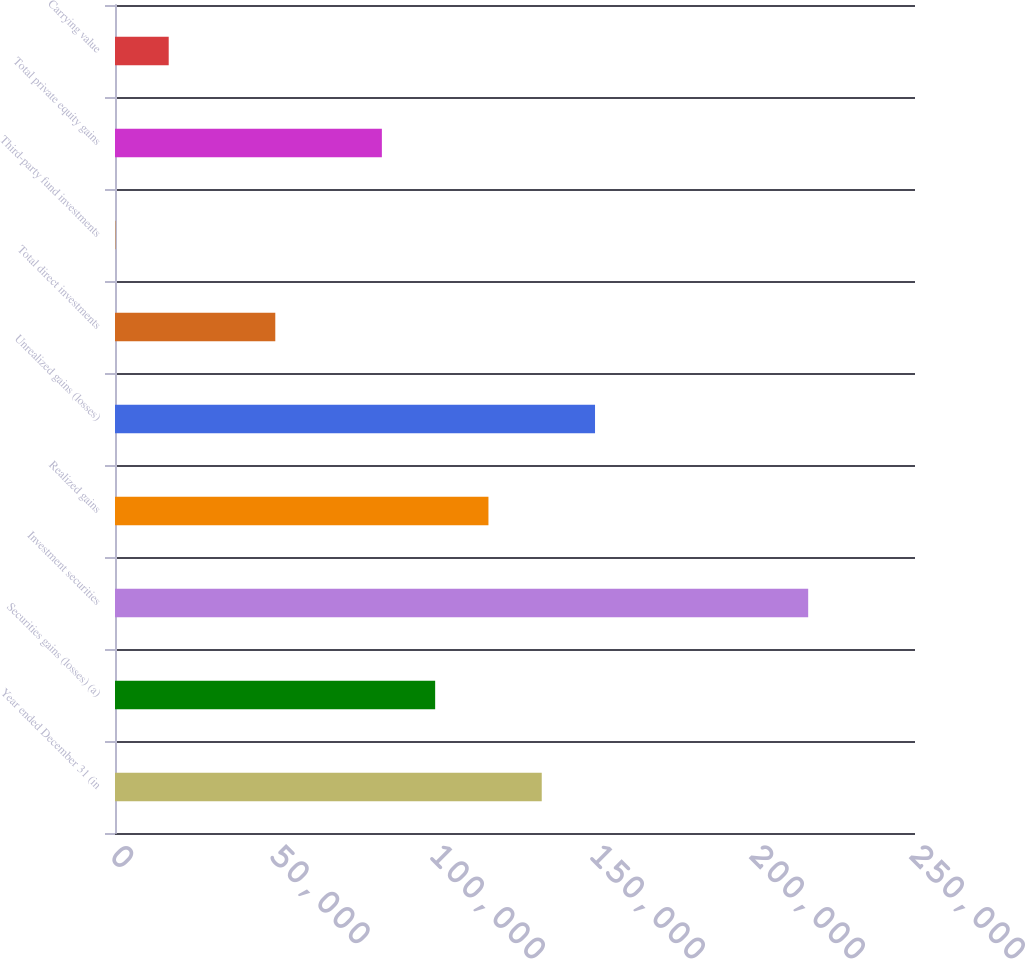Convert chart to OTSL. <chart><loc_0><loc_0><loc_500><loc_500><bar_chart><fcel>Year ended December 31 (in<fcel>Securities gains (losses) (a)<fcel>Investment securities<fcel>Realized gains<fcel>Unrealized gains (losses)<fcel>Total direct investments<fcel>Third-party fund investments<fcel>Total private equity gains<fcel>Carrying value<nl><fcel>133356<fcel>100050<fcel>216621<fcel>116703<fcel>150009<fcel>50090.3<fcel>131<fcel>83396.5<fcel>16784.1<nl></chart> 